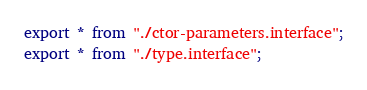<code> <loc_0><loc_0><loc_500><loc_500><_TypeScript_>export * from "./ctor-parameters.interface";
export * from "./type.interface";
</code> 